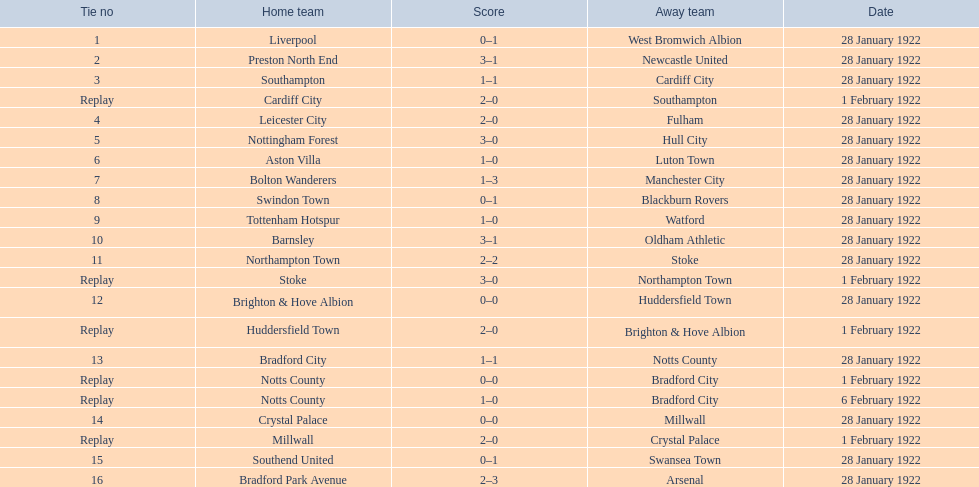What was the result of the aston villa match? 1–0. Can you name another team that had the same score? Tottenham Hotspur. 